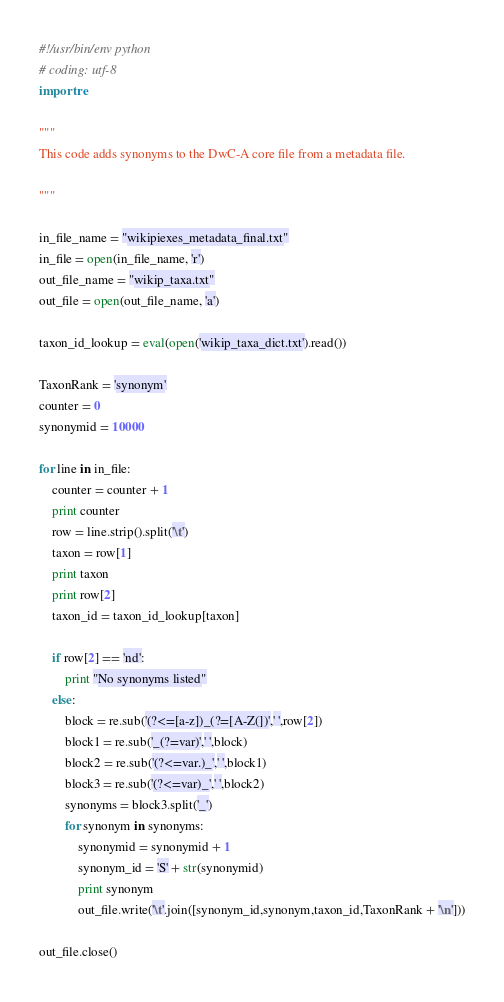<code> <loc_0><loc_0><loc_500><loc_500><_Python_>#!/usr/bin/env python
# coding: utf-8
import re

"""
This code adds synonyms to the DwC-A core file from a metadata file.
 
"""

in_file_name = "wikipiexes_metadata_final.txt"
in_file = open(in_file_name, 'r')
out_file_name = "wikip_taxa.txt"
out_file = open(out_file_name, 'a')

taxon_id_lookup = eval(open('wikip_taxa_dict.txt').read())

TaxonRank = 'synonym'
counter = 0
synonymid = 10000

for line in in_file:
	counter = counter + 1
	print counter
	row = line.strip().split('\t')
	taxon = row[1]
	print taxon
	print row[2]
	taxon_id = taxon_id_lookup[taxon]
	
	if row[2] == 'nd':
		print "No synonyms listed"
	else:
		block = re.sub('(?<=[a-z])_(?=[A-Z(])',' ',row[2])
		block1 = re.sub('_(?=var)',' ',block)
		block2 = re.sub('(?<=var.)_',' ',block1)
		block3 = re.sub('(?<=var)_',' ',block2)
		synonyms = block3.split('_')
		for synonym in synonyms:
			synonymid = synonymid + 1
			synonym_id = 'S' + str(synonymid)
			print synonym
			out_file.write('\t'.join([synonym_id,synonym,taxon_id,TaxonRank + '\n']))

out_file.close()
</code> 